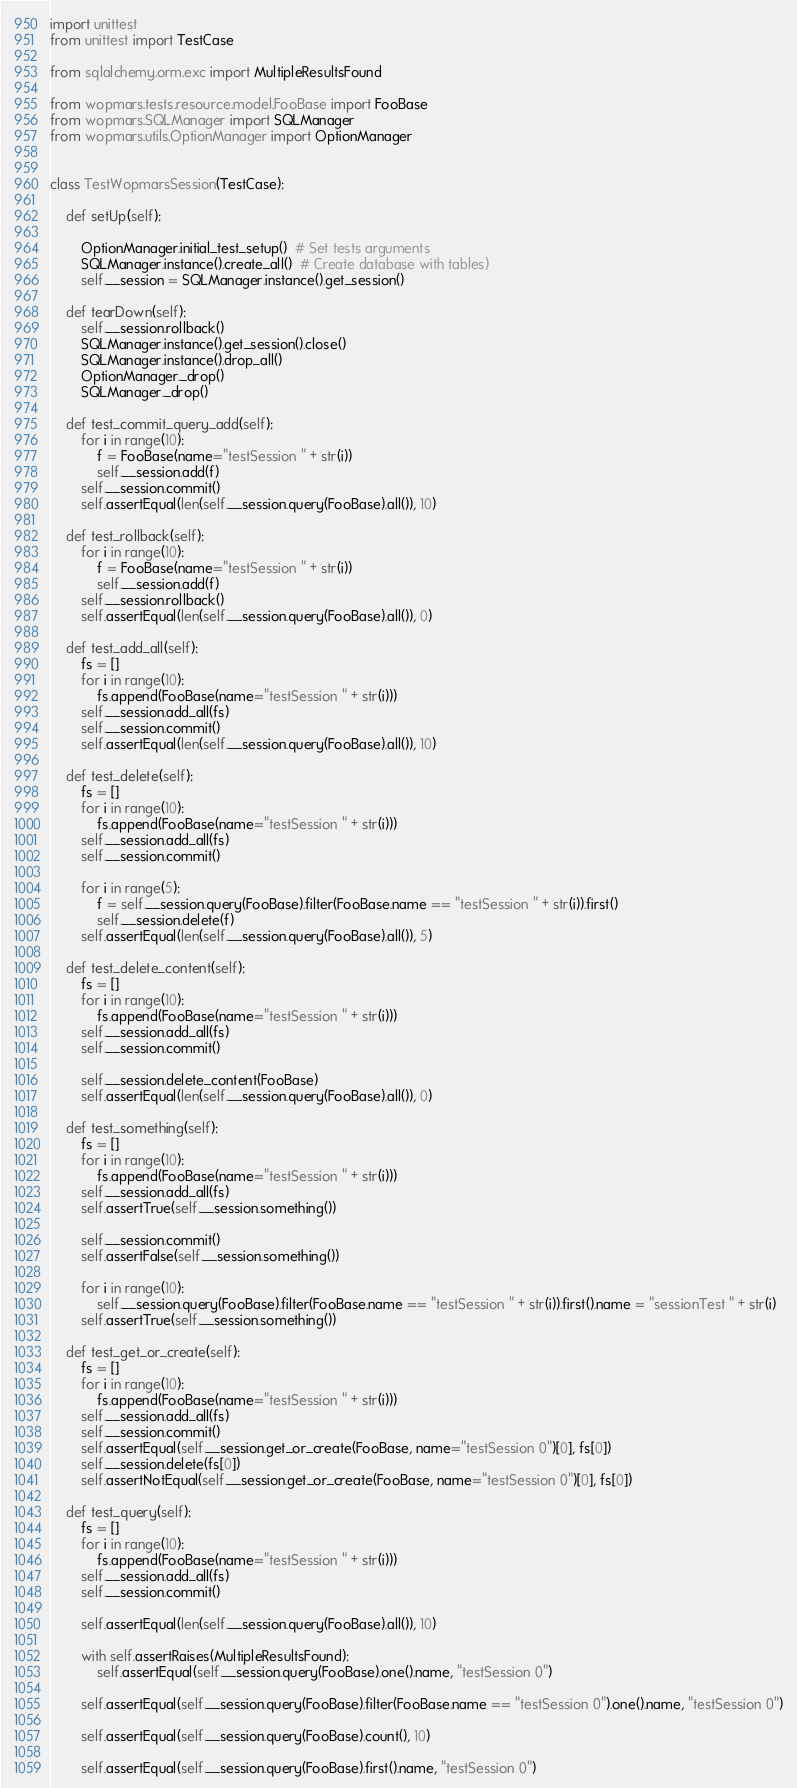<code> <loc_0><loc_0><loc_500><loc_500><_Python_>import unittest
from unittest import TestCase

from sqlalchemy.orm.exc import MultipleResultsFound

from wopmars.tests.resource.model.FooBase import FooBase
from wopmars.SQLManager import SQLManager
from wopmars.utils.OptionManager import OptionManager


class TestWopmarsSession(TestCase):

    def setUp(self):

        OptionManager.initial_test_setup()  # Set tests arguments
        SQLManager.instance().create_all()  # Create database with tables)
        self.__session = SQLManager.instance().get_session()

    def tearDown(self):
        self.__session.rollback()
        SQLManager.instance().get_session().close()
        SQLManager.instance().drop_all()
        OptionManager._drop()
        SQLManager._drop()

    def test_commit_query_add(self):
        for i in range(10):
            f = FooBase(name="testSession " + str(i))
            self.__session.add(f)
        self.__session.commit()
        self.assertEqual(len(self.__session.query(FooBase).all()), 10)

    def test_rollback(self):
        for i in range(10):
            f = FooBase(name="testSession " + str(i))
            self.__session.add(f)
        self.__session.rollback()
        self.assertEqual(len(self.__session.query(FooBase).all()), 0)

    def test_add_all(self):
        fs = []
        for i in range(10):
            fs.append(FooBase(name="testSession " + str(i)))
        self.__session.add_all(fs)
        self.__session.commit()
        self.assertEqual(len(self.__session.query(FooBase).all()), 10)

    def test_delete(self):
        fs = []
        for i in range(10):
            fs.append(FooBase(name="testSession " + str(i)))
        self.__session.add_all(fs)
        self.__session.commit()

        for i in range(5):
            f = self.__session.query(FooBase).filter(FooBase.name == "testSession " + str(i)).first()
            self.__session.delete(f)
        self.assertEqual(len(self.__session.query(FooBase).all()), 5)

    def test_delete_content(self):
        fs = []
        for i in range(10):
            fs.append(FooBase(name="testSession " + str(i)))
        self.__session.add_all(fs)
        self.__session.commit()

        self.__session.delete_content(FooBase)
        self.assertEqual(len(self.__session.query(FooBase).all()), 0)

    def test_something(self):
        fs = []
        for i in range(10):
            fs.append(FooBase(name="testSession " + str(i)))
        self.__session.add_all(fs)
        self.assertTrue(self.__session.something())

        self.__session.commit()
        self.assertFalse(self.__session.something())

        for i in range(10):
            self.__session.query(FooBase).filter(FooBase.name == "testSession " + str(i)).first().name = "sessionTest " + str(i)
        self.assertTrue(self.__session.something())

    def test_get_or_create(self):
        fs = []
        for i in range(10):
            fs.append(FooBase(name="testSession " + str(i)))
        self.__session.add_all(fs)
        self.__session.commit()
        self.assertEqual(self.__session.get_or_create(FooBase, name="testSession 0")[0], fs[0])
        self.__session.delete(fs[0])
        self.assertNotEqual(self.__session.get_or_create(FooBase, name="testSession 0")[0], fs[0])

    def test_query(self):
        fs = []
        for i in range(10):
            fs.append(FooBase(name="testSession " + str(i)))
        self.__session.add_all(fs)
        self.__session.commit()

        self.assertEqual(len(self.__session.query(FooBase).all()), 10)

        with self.assertRaises(MultipleResultsFound):
            self.assertEqual(self.__session.query(FooBase).one().name, "testSession 0")

        self.assertEqual(self.__session.query(FooBase).filter(FooBase.name == "testSession 0").one().name, "testSession 0")

        self.assertEqual(self.__session.query(FooBase).count(), 10)

        self.assertEqual(self.__session.query(FooBase).first().name, "testSession 0")
</code> 